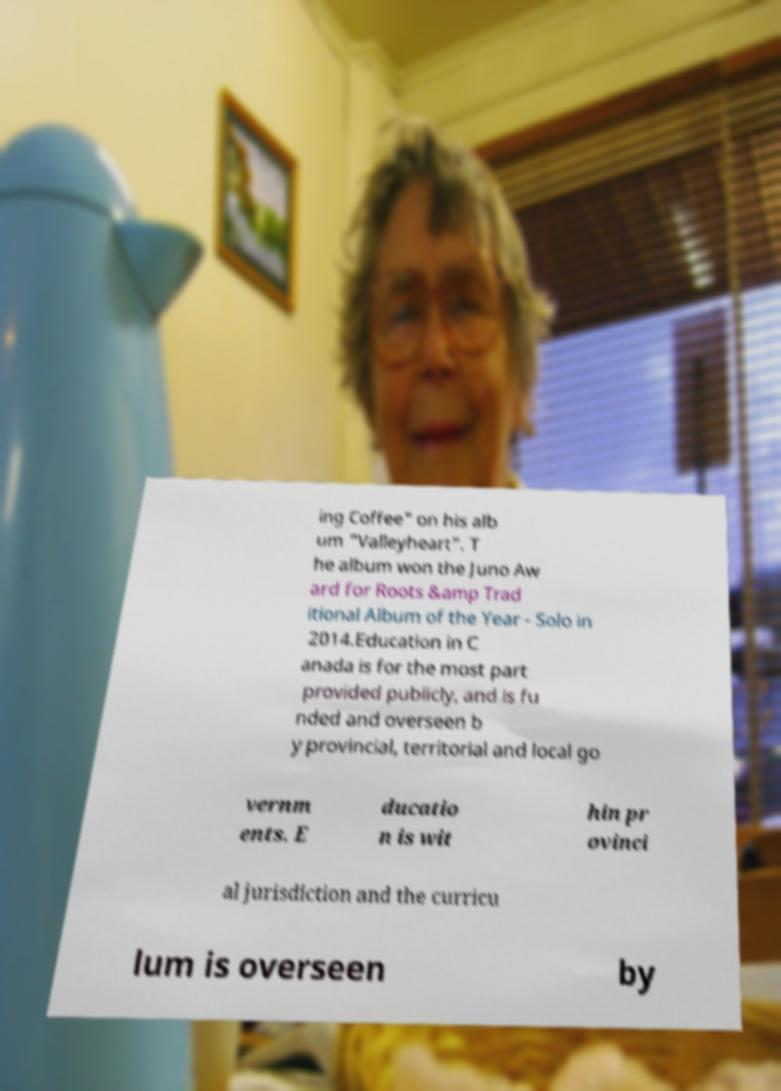Please identify and transcribe the text found in this image. ing Coffee" on his alb um "Valleyheart". T he album won the Juno Aw ard for Roots &amp Trad itional Album of the Year - Solo in 2014.Education in C anada is for the most part provided publicly, and is fu nded and overseen b y provincial, territorial and local go vernm ents. E ducatio n is wit hin pr ovinci al jurisdiction and the curricu lum is overseen by 